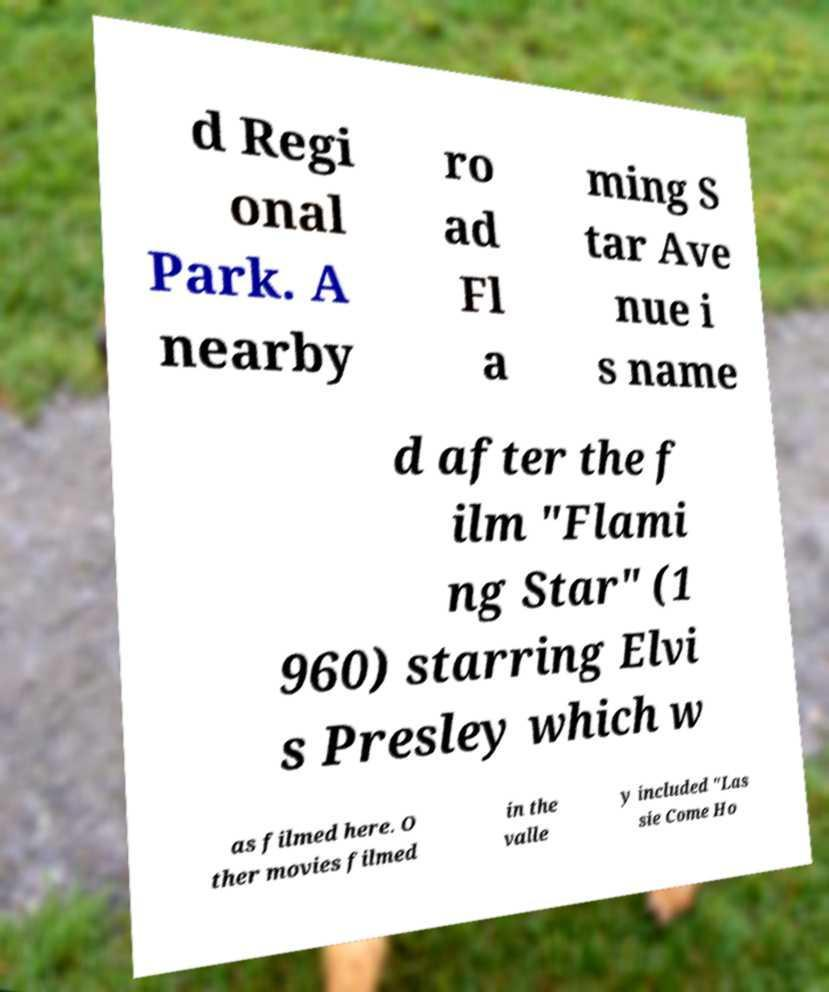Can you accurately transcribe the text from the provided image for me? d Regi onal Park. A nearby ro ad Fl a ming S tar Ave nue i s name d after the f ilm "Flami ng Star" (1 960) starring Elvi s Presley which w as filmed here. O ther movies filmed in the valle y included "Las sie Come Ho 